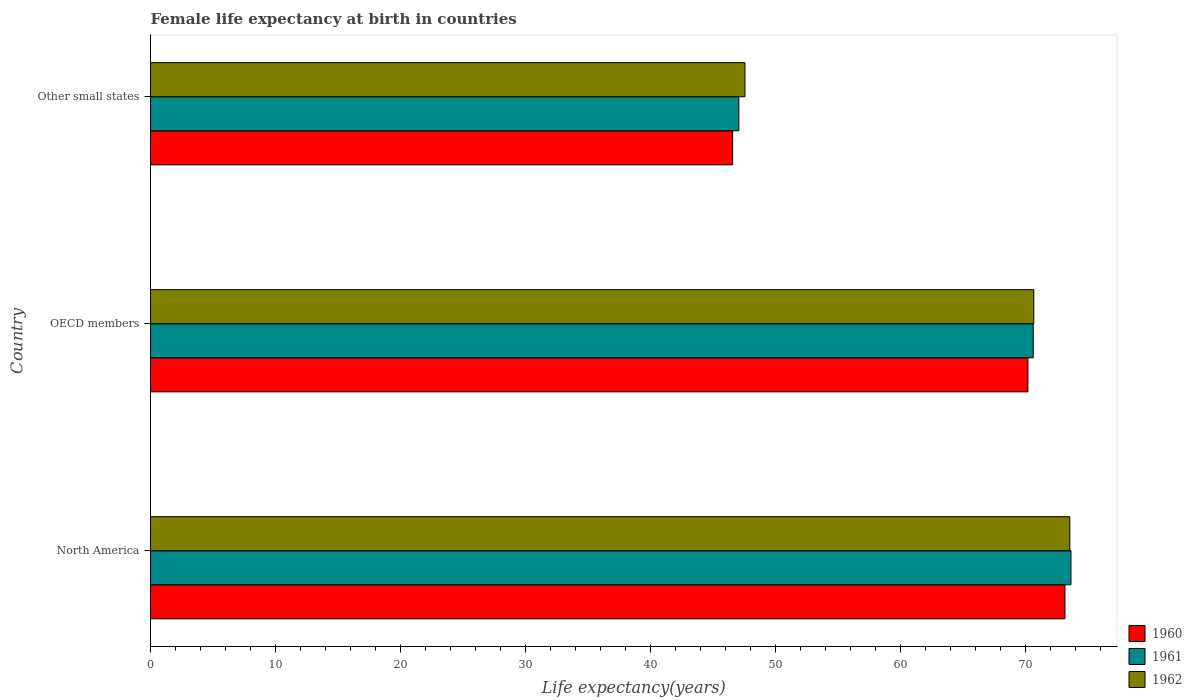How many different coloured bars are there?
Your answer should be compact. 3. How many groups of bars are there?
Offer a very short reply. 3. Are the number of bars per tick equal to the number of legend labels?
Make the answer very short. Yes. Are the number of bars on each tick of the Y-axis equal?
Provide a succinct answer. Yes. What is the label of the 3rd group of bars from the top?
Your answer should be compact. North America. In how many cases, is the number of bars for a given country not equal to the number of legend labels?
Keep it short and to the point. 0. What is the female life expectancy at birth in 1961 in Other small states?
Provide a short and direct response. 47.09. Across all countries, what is the maximum female life expectancy at birth in 1962?
Offer a very short reply. 73.58. Across all countries, what is the minimum female life expectancy at birth in 1960?
Your answer should be very brief. 46.59. In which country was the female life expectancy at birth in 1962 minimum?
Your answer should be compact. Other small states. What is the total female life expectancy at birth in 1960 in the graph?
Keep it short and to the point. 190.01. What is the difference between the female life expectancy at birth in 1960 in OECD members and that in Other small states?
Give a very brief answer. 23.64. What is the difference between the female life expectancy at birth in 1961 in North America and the female life expectancy at birth in 1960 in Other small states?
Offer a very short reply. 27.08. What is the average female life expectancy at birth in 1961 per country?
Give a very brief answer. 63.81. What is the difference between the female life expectancy at birth in 1962 and female life expectancy at birth in 1960 in North America?
Keep it short and to the point. 0.39. In how many countries, is the female life expectancy at birth in 1960 greater than 48 years?
Provide a succinct answer. 2. What is the ratio of the female life expectancy at birth in 1961 in North America to that in OECD members?
Give a very brief answer. 1.04. What is the difference between the highest and the second highest female life expectancy at birth in 1961?
Offer a very short reply. 3.02. What is the difference between the highest and the lowest female life expectancy at birth in 1962?
Ensure brevity in your answer.  26. What does the 1st bar from the top in OECD members represents?
Offer a terse response. 1962. How many bars are there?
Provide a short and direct response. 9. Are all the bars in the graph horizontal?
Ensure brevity in your answer.  Yes. How many countries are there in the graph?
Make the answer very short. 3. What is the difference between two consecutive major ticks on the X-axis?
Make the answer very short. 10. Does the graph contain any zero values?
Your answer should be compact. No. How many legend labels are there?
Offer a terse response. 3. How are the legend labels stacked?
Offer a terse response. Vertical. What is the title of the graph?
Provide a short and direct response. Female life expectancy at birth in countries. Does "1973" appear as one of the legend labels in the graph?
Your answer should be very brief. No. What is the label or title of the X-axis?
Your response must be concise. Life expectancy(years). What is the Life expectancy(years) of 1960 in North America?
Offer a terse response. 73.19. What is the Life expectancy(years) in 1961 in North America?
Make the answer very short. 73.68. What is the Life expectancy(years) of 1962 in North America?
Your answer should be compact. 73.58. What is the Life expectancy(years) of 1960 in OECD members?
Give a very brief answer. 70.23. What is the Life expectancy(years) of 1961 in OECD members?
Offer a very short reply. 70.65. What is the Life expectancy(years) of 1962 in OECD members?
Your answer should be compact. 70.7. What is the Life expectancy(years) in 1960 in Other small states?
Provide a short and direct response. 46.59. What is the Life expectancy(years) of 1961 in Other small states?
Your answer should be very brief. 47.09. What is the Life expectancy(years) in 1962 in Other small states?
Give a very brief answer. 47.58. Across all countries, what is the maximum Life expectancy(years) of 1960?
Ensure brevity in your answer.  73.19. Across all countries, what is the maximum Life expectancy(years) in 1961?
Your answer should be compact. 73.68. Across all countries, what is the maximum Life expectancy(years) of 1962?
Give a very brief answer. 73.58. Across all countries, what is the minimum Life expectancy(years) in 1960?
Give a very brief answer. 46.59. Across all countries, what is the minimum Life expectancy(years) of 1961?
Your answer should be very brief. 47.09. Across all countries, what is the minimum Life expectancy(years) of 1962?
Give a very brief answer. 47.58. What is the total Life expectancy(years) in 1960 in the graph?
Provide a short and direct response. 190.01. What is the total Life expectancy(years) in 1961 in the graph?
Offer a very short reply. 191.42. What is the total Life expectancy(years) of 1962 in the graph?
Give a very brief answer. 191.86. What is the difference between the Life expectancy(years) of 1960 in North America and that in OECD members?
Make the answer very short. 2.96. What is the difference between the Life expectancy(years) in 1961 in North America and that in OECD members?
Your answer should be very brief. 3.02. What is the difference between the Life expectancy(years) of 1962 in North America and that in OECD members?
Offer a very short reply. 2.88. What is the difference between the Life expectancy(years) in 1960 in North America and that in Other small states?
Give a very brief answer. 26.6. What is the difference between the Life expectancy(years) of 1961 in North America and that in Other small states?
Offer a very short reply. 26.58. What is the difference between the Life expectancy(years) in 1962 in North America and that in Other small states?
Offer a terse response. 26. What is the difference between the Life expectancy(years) in 1960 in OECD members and that in Other small states?
Your response must be concise. 23.64. What is the difference between the Life expectancy(years) of 1961 in OECD members and that in Other small states?
Offer a terse response. 23.56. What is the difference between the Life expectancy(years) of 1962 in OECD members and that in Other small states?
Give a very brief answer. 23.12. What is the difference between the Life expectancy(years) of 1960 in North America and the Life expectancy(years) of 1961 in OECD members?
Make the answer very short. 2.54. What is the difference between the Life expectancy(years) in 1960 in North America and the Life expectancy(years) in 1962 in OECD members?
Provide a succinct answer. 2.49. What is the difference between the Life expectancy(years) in 1961 in North America and the Life expectancy(years) in 1962 in OECD members?
Make the answer very short. 2.98. What is the difference between the Life expectancy(years) of 1960 in North America and the Life expectancy(years) of 1961 in Other small states?
Provide a succinct answer. 26.1. What is the difference between the Life expectancy(years) of 1960 in North America and the Life expectancy(years) of 1962 in Other small states?
Provide a short and direct response. 25.61. What is the difference between the Life expectancy(years) in 1961 in North America and the Life expectancy(years) in 1962 in Other small states?
Provide a succinct answer. 26.1. What is the difference between the Life expectancy(years) of 1960 in OECD members and the Life expectancy(years) of 1961 in Other small states?
Keep it short and to the point. 23.14. What is the difference between the Life expectancy(years) in 1960 in OECD members and the Life expectancy(years) in 1962 in Other small states?
Offer a very short reply. 22.65. What is the difference between the Life expectancy(years) in 1961 in OECD members and the Life expectancy(years) in 1962 in Other small states?
Offer a very short reply. 23.08. What is the average Life expectancy(years) in 1960 per country?
Provide a succinct answer. 63.34. What is the average Life expectancy(years) of 1961 per country?
Your response must be concise. 63.81. What is the average Life expectancy(years) of 1962 per country?
Ensure brevity in your answer.  63.95. What is the difference between the Life expectancy(years) in 1960 and Life expectancy(years) in 1961 in North America?
Your response must be concise. -0.48. What is the difference between the Life expectancy(years) of 1960 and Life expectancy(years) of 1962 in North America?
Keep it short and to the point. -0.39. What is the difference between the Life expectancy(years) of 1961 and Life expectancy(years) of 1962 in North America?
Ensure brevity in your answer.  0.09. What is the difference between the Life expectancy(years) of 1960 and Life expectancy(years) of 1961 in OECD members?
Your response must be concise. -0.42. What is the difference between the Life expectancy(years) of 1960 and Life expectancy(years) of 1962 in OECD members?
Your answer should be compact. -0.47. What is the difference between the Life expectancy(years) in 1961 and Life expectancy(years) in 1962 in OECD members?
Provide a succinct answer. -0.05. What is the difference between the Life expectancy(years) in 1960 and Life expectancy(years) in 1961 in Other small states?
Your response must be concise. -0.5. What is the difference between the Life expectancy(years) of 1960 and Life expectancy(years) of 1962 in Other small states?
Ensure brevity in your answer.  -0.99. What is the difference between the Life expectancy(years) of 1961 and Life expectancy(years) of 1962 in Other small states?
Keep it short and to the point. -0.49. What is the ratio of the Life expectancy(years) in 1960 in North America to that in OECD members?
Your response must be concise. 1.04. What is the ratio of the Life expectancy(years) of 1961 in North America to that in OECD members?
Your answer should be very brief. 1.04. What is the ratio of the Life expectancy(years) of 1962 in North America to that in OECD members?
Your answer should be very brief. 1.04. What is the ratio of the Life expectancy(years) of 1960 in North America to that in Other small states?
Provide a short and direct response. 1.57. What is the ratio of the Life expectancy(years) of 1961 in North America to that in Other small states?
Make the answer very short. 1.56. What is the ratio of the Life expectancy(years) in 1962 in North America to that in Other small states?
Your answer should be compact. 1.55. What is the ratio of the Life expectancy(years) of 1960 in OECD members to that in Other small states?
Offer a terse response. 1.51. What is the ratio of the Life expectancy(years) in 1961 in OECD members to that in Other small states?
Keep it short and to the point. 1.5. What is the ratio of the Life expectancy(years) in 1962 in OECD members to that in Other small states?
Your answer should be compact. 1.49. What is the difference between the highest and the second highest Life expectancy(years) of 1960?
Keep it short and to the point. 2.96. What is the difference between the highest and the second highest Life expectancy(years) of 1961?
Provide a succinct answer. 3.02. What is the difference between the highest and the second highest Life expectancy(years) in 1962?
Make the answer very short. 2.88. What is the difference between the highest and the lowest Life expectancy(years) of 1960?
Offer a very short reply. 26.6. What is the difference between the highest and the lowest Life expectancy(years) of 1961?
Provide a short and direct response. 26.58. What is the difference between the highest and the lowest Life expectancy(years) in 1962?
Ensure brevity in your answer.  26. 